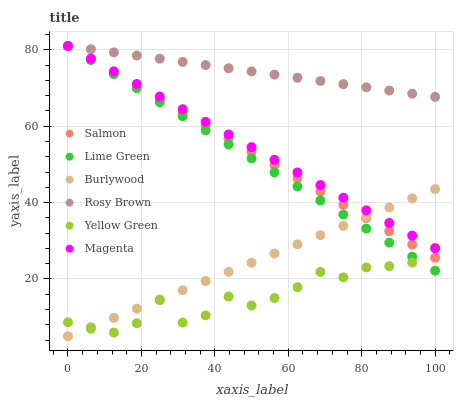Does Yellow Green have the minimum area under the curve?
Answer yes or no. Yes. Does Rosy Brown have the maximum area under the curve?
Answer yes or no. Yes. Does Burlywood have the minimum area under the curve?
Answer yes or no. No. Does Burlywood have the maximum area under the curve?
Answer yes or no. No. Is Burlywood the smoothest?
Answer yes or no. Yes. Is Yellow Green the roughest?
Answer yes or no. Yes. Is Rosy Brown the smoothest?
Answer yes or no. No. Is Rosy Brown the roughest?
Answer yes or no. No. Does Burlywood have the lowest value?
Answer yes or no. Yes. Does Rosy Brown have the lowest value?
Answer yes or no. No. Does Lime Green have the highest value?
Answer yes or no. Yes. Does Burlywood have the highest value?
Answer yes or no. No. Is Burlywood less than Rosy Brown?
Answer yes or no. Yes. Is Rosy Brown greater than Burlywood?
Answer yes or no. Yes. Does Yellow Green intersect Salmon?
Answer yes or no. Yes. Is Yellow Green less than Salmon?
Answer yes or no. No. Is Yellow Green greater than Salmon?
Answer yes or no. No. Does Burlywood intersect Rosy Brown?
Answer yes or no. No. 